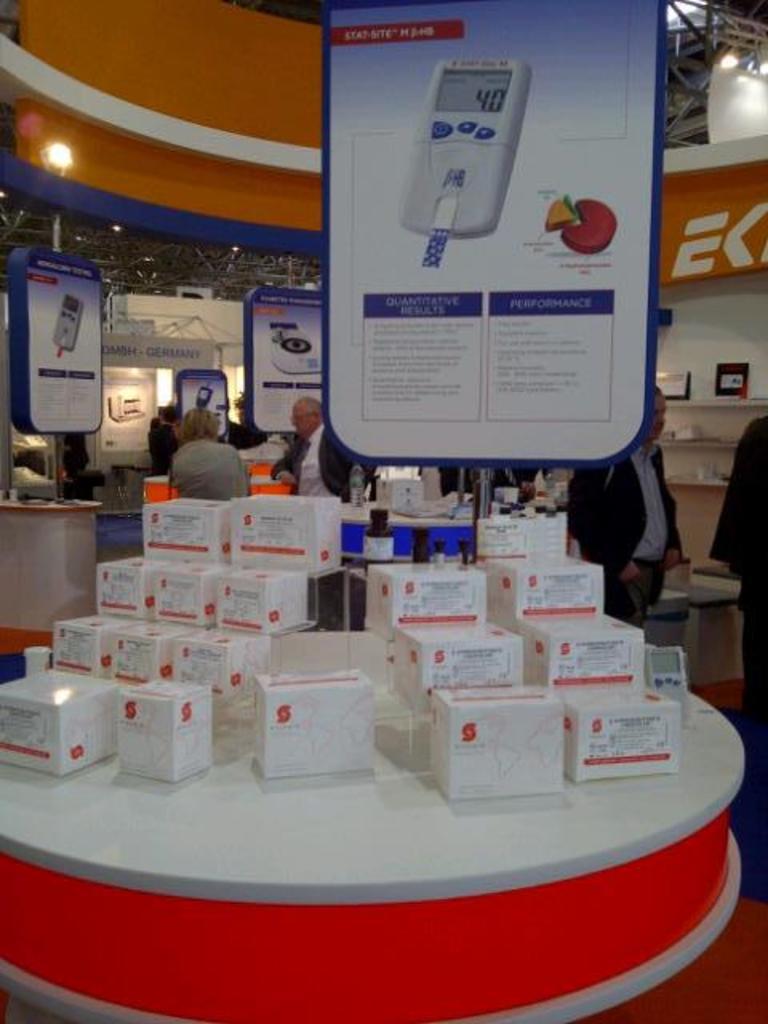What is the number on the diabetic testing machine?
Offer a very short reply. 40. 